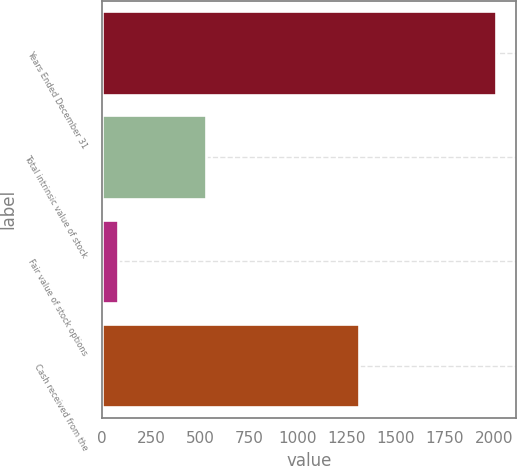<chart> <loc_0><loc_0><loc_500><loc_500><bar_chart><fcel>Years Ended December 31<fcel>Total intrinsic value of stock<fcel>Fair value of stock options<fcel>Cash received from the<nl><fcel>2012<fcel>528<fcel>80<fcel>1310<nl></chart> 